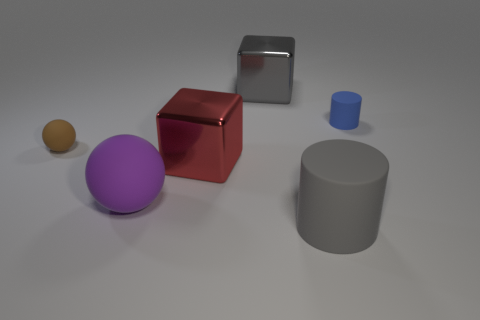Is the large rubber sphere the same color as the tiny matte sphere?
Your response must be concise. No. Are there any tiny gray objects that have the same shape as the large purple rubber object?
Your response must be concise. No. Does the rubber ball behind the purple object have the same size as the large purple object?
Provide a short and direct response. No. Are there any small matte objects?
Offer a very short reply. Yes. What number of things are large things behind the big matte sphere or big yellow objects?
Your answer should be compact. 2. There is a big rubber cylinder; is its color the same as the shiny object in front of the gray shiny cube?
Your answer should be compact. No. Are there any other blue things that have the same size as the blue matte thing?
Keep it short and to the point. No. What material is the big gray object that is behind the cylinder that is on the right side of the large rubber cylinder?
Keep it short and to the point. Metal. How many metallic cubes are the same color as the small cylinder?
Keep it short and to the point. 0. What shape is the gray thing that is the same material as the big sphere?
Make the answer very short. Cylinder. 